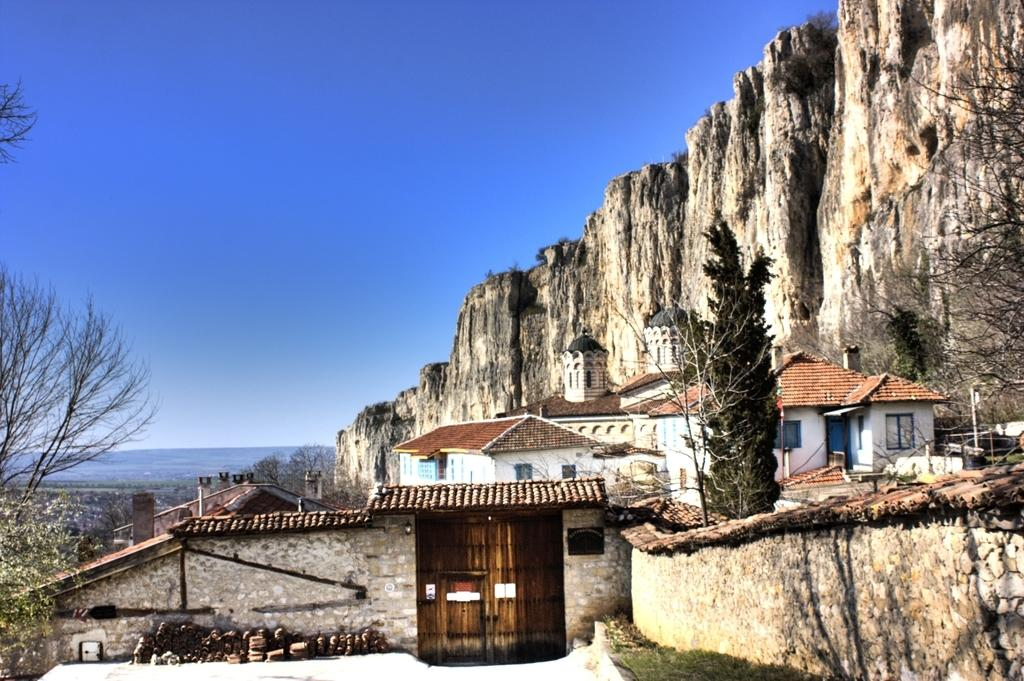What type of structures can be seen in the image? There are buildings in the image. What other natural elements are present in the image? There are trees in the image. What are the vertical structures on the streets in the image? Street poles are visible in the image. What type of lighting is present on the streets in the image? Street lights are present in the image. What type of landscape feature can be seen in the distance in the image? Hills are visible in the image. What is visible above the buildings and trees in the image? The sky is visible in the image. How many zebras can be seen grazing on the hills in the image? There are no zebras present in the image; it features buildings, trees, street poles, street lights, and hills. What type of insect is flying around the street lights in the image? There are no insects visible in the image; it only shows buildings, trees, street poles, street lights, and hills. 